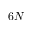Convert formula to latex. <formula><loc_0><loc_0><loc_500><loc_500>6 N</formula> 